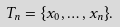Convert formula to latex. <formula><loc_0><loc_0><loc_500><loc_500>T _ { n } = \{ x _ { 0 } , \dots , x _ { n } \} .</formula> 